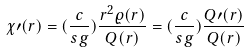Convert formula to latex. <formula><loc_0><loc_0><loc_500><loc_500>\chi \prime ( r ) = ( \frac { c } { s g } ) \frac { r ^ { 2 } \varrho ( r ) } { Q ( r ) } = ( \frac { c } { s g } ) \frac { Q \prime ( r ) } { Q ( r ) }</formula> 